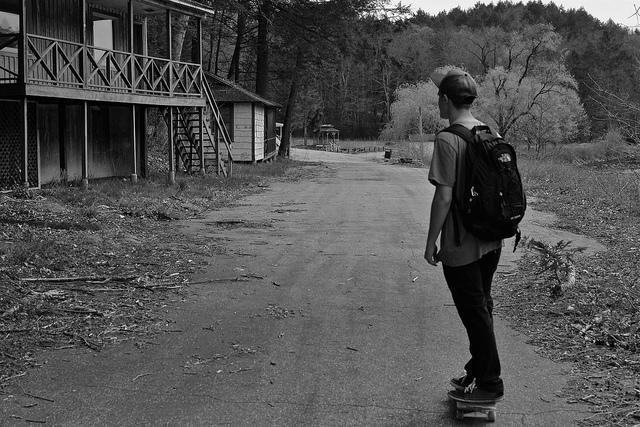How many people are in this picture?
Give a very brief answer. 1. How many people are there?
Give a very brief answer. 1. How many fence pickets are visible in the picture?
Give a very brief answer. 0. How many people wear sneakers?
Give a very brief answer. 1. How many buildings are seen in the photo?
Give a very brief answer. 2. How many people are riding skateboards on this street?
Give a very brief answer. 1. 